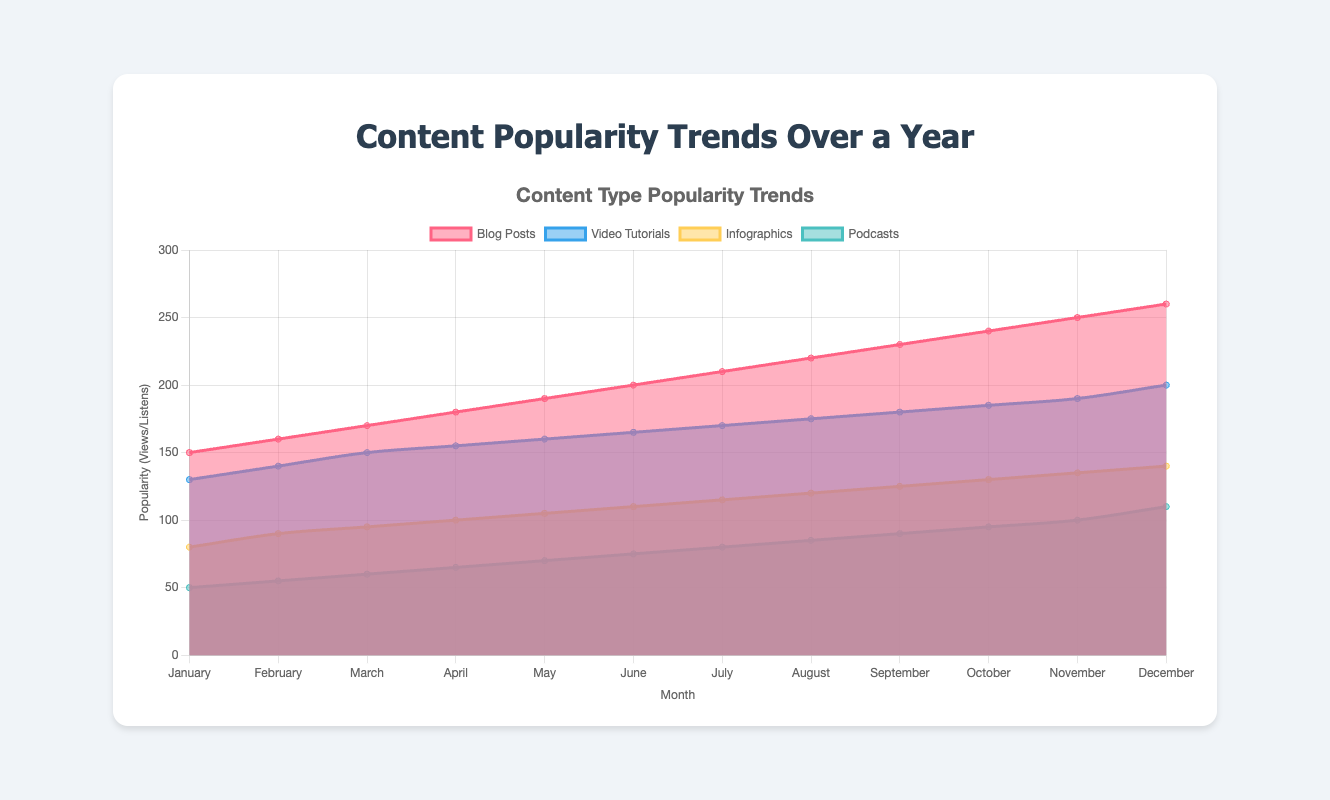What is the most popular content type in December? To determine this, we look at the data for December and find the content type with the highest value. Blog Posts: 260, Video Tutorials: 200, Infographics: 140, Podcasts: 110. Blog Posts have the highest value.
Answer: Blog Posts Which content type showed the smallest increase in popularity from January to December? Calculate the difference between January and December for each content type. Blog Posts increased by 260 - 150 = 110, Video Tutorials increased by 200 - 130 = 70, Infographics increased by 140 - 80 = 60, Podcasts increased by 110 - 50 = 60. Infographics and Podcasts showed the smallest increase of 60.
Answer: Infographics and Podcasts What is the trend for video tutorials across the year? To observe the trend, check the data points for Video Tutorials from January to December. The values increase from 130 in January to 200 in December, indicating a gradual upward trend.
Answer: Upward trend Which month saw the highest increase in popularity for blog posts from the previous month? Calculate the increase in Blog Posts for each consecutive month. The highest increase is from November (250) to December (260), which is 10.
Answer: December By how much did the popularity of podcasts change from June to July? Subtract the value in June from the value in July for Podcasts. July: 80, June: 75, so the change is 80 - 75 = 5.
Answer: 5 What is the total popularity for infographics in the first half of the year (January to June)? Sum the values of Infographics from January to June. 80 + 90 + 95 + 100 + 105 + 110 = 580.
Answer: 580 Which month had the least popular video tutorials? Look for the lowest value in the dataset for Video Tutorials. The lowest value is in January, with 130 views.
Answer: January How does the popularity of infographics in March compare to that of podcasts in the same month? Check the values for Infographics and Podcasts in March. Infographics: 95, Podcasts: 60. Infographics are more popular in March.
Answer: Infographics are more popular What content type had a consistent increase every month? By examining the data for each content type, Blog Posts, Video Tutorials, Infographics, and Podcasts all show consistent increases every month.
Answer: All content types (Blog Posts, Video Tutorials, Infographics, Podcasts) What is the slope of the trend line for blog posts if plotted on a graph with months on the x-axis and popularity on the y-axis? The trend for Blog Posts is linear, so the slope (rate of change) can be calculated by (Change in popularity) / (Change in time). From January to December, the change in popularity is 260 - 150 = 110 and the change in time is 11 (December - January). So, the slope is 110/11 ≈ 10.
Answer: 10 